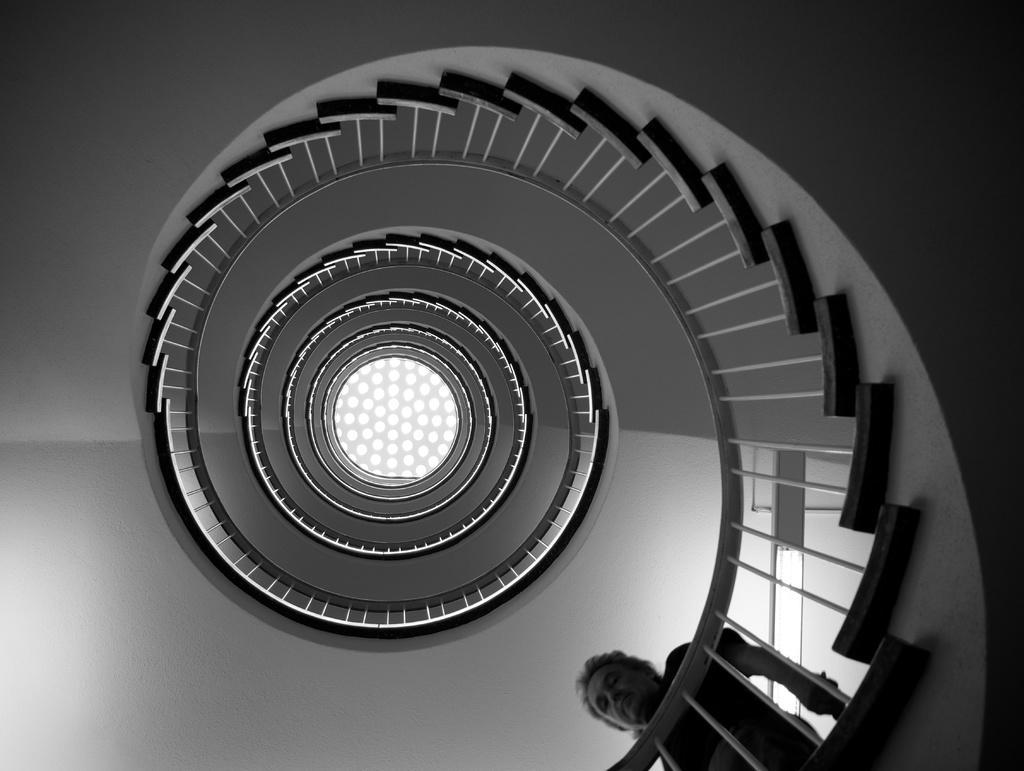Describe this image in one or two sentences. This is a black and white image. In this image we can see a man walking downstairs. We can also see a roof with some lights. 